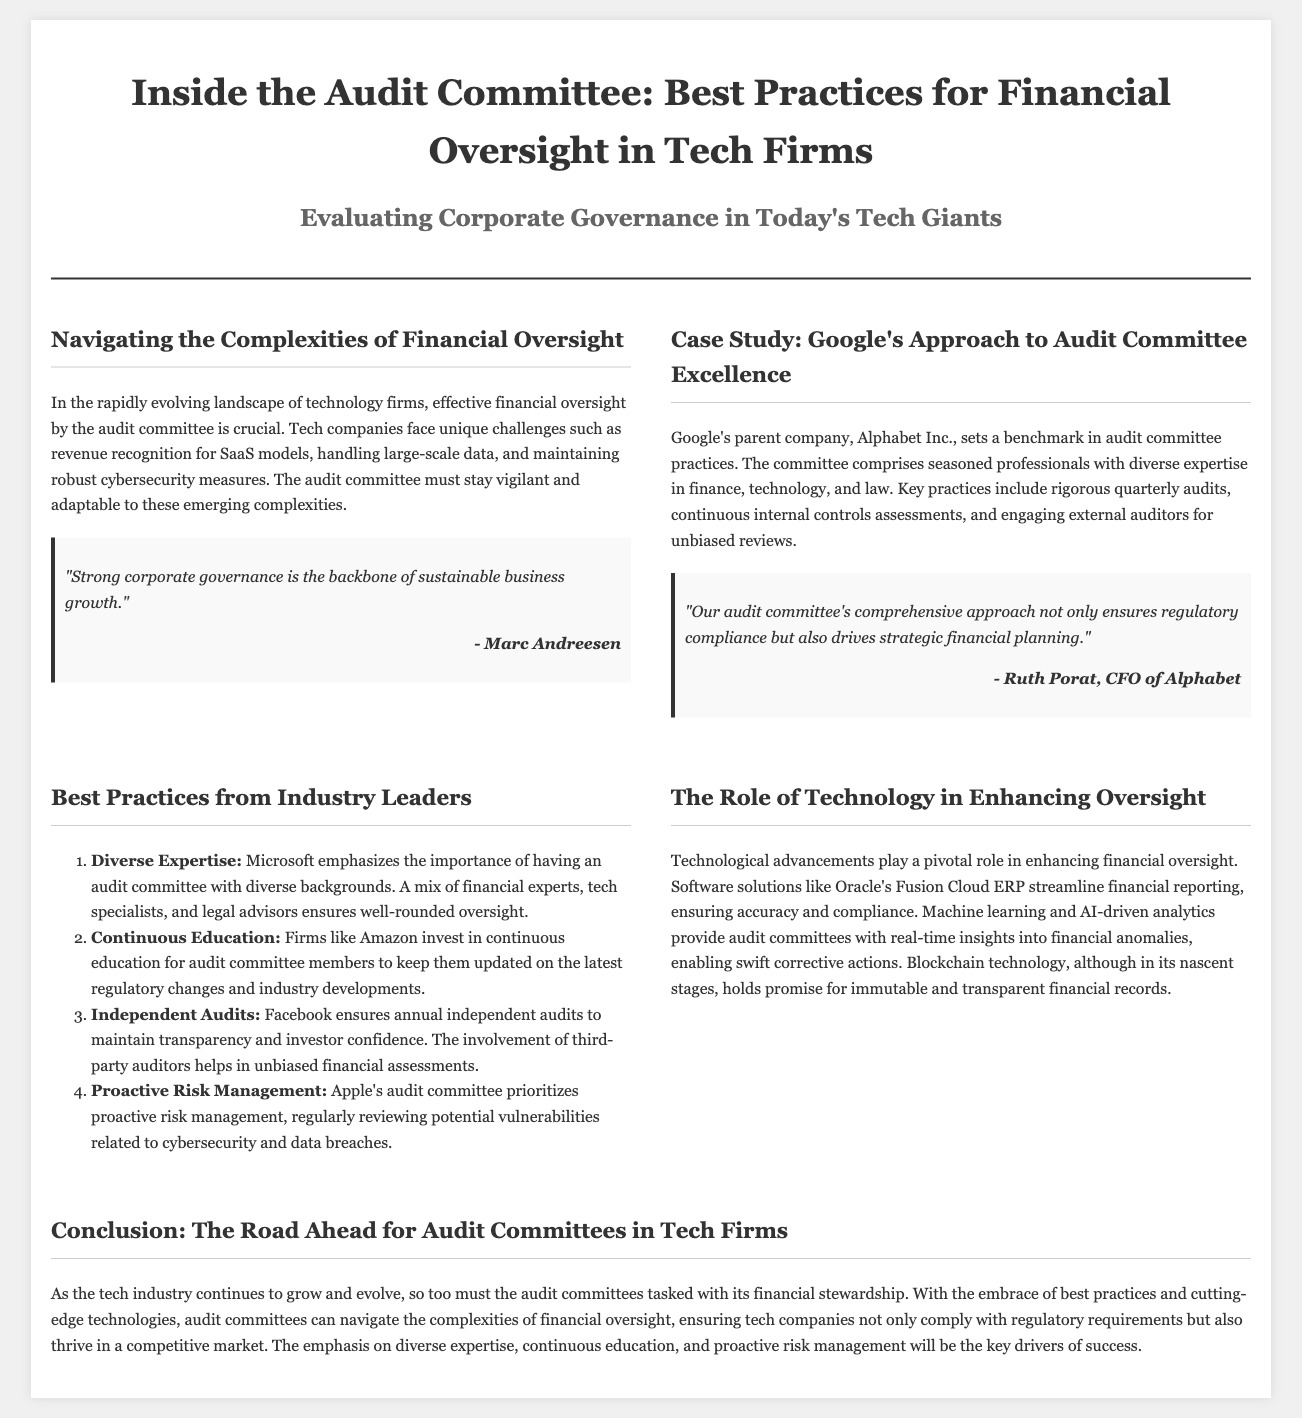What is the main focus of the audit committee in tech firms? The main focus of the audit committee is effective financial oversight, particularly in navigating complexities such as revenue recognition for SaaS models and maintaining robust cybersecurity measures.
Answer: effective financial oversight Who is the CFO of Alphabet Inc.? The CFO of Alphabet Inc. is Ruth Porat.
Answer: Ruth Porat Which company emphasizes the importance of diverse expertise in their audit committee? Microsoft emphasizes the importance of having an audit committee with diverse backgrounds.
Answer: Microsoft What technology is mentioned as promising for immutable financial records? Blockchain technology is mentioned as promising for immutable financial records.
Answer: Blockchain technology How does Apple prioritize risk management in its audit committee? Apple prioritizes proactive risk management by regularly reviewing potential vulnerabilities related to cybersecurity and data breaches.
Answer: proactive risk management 